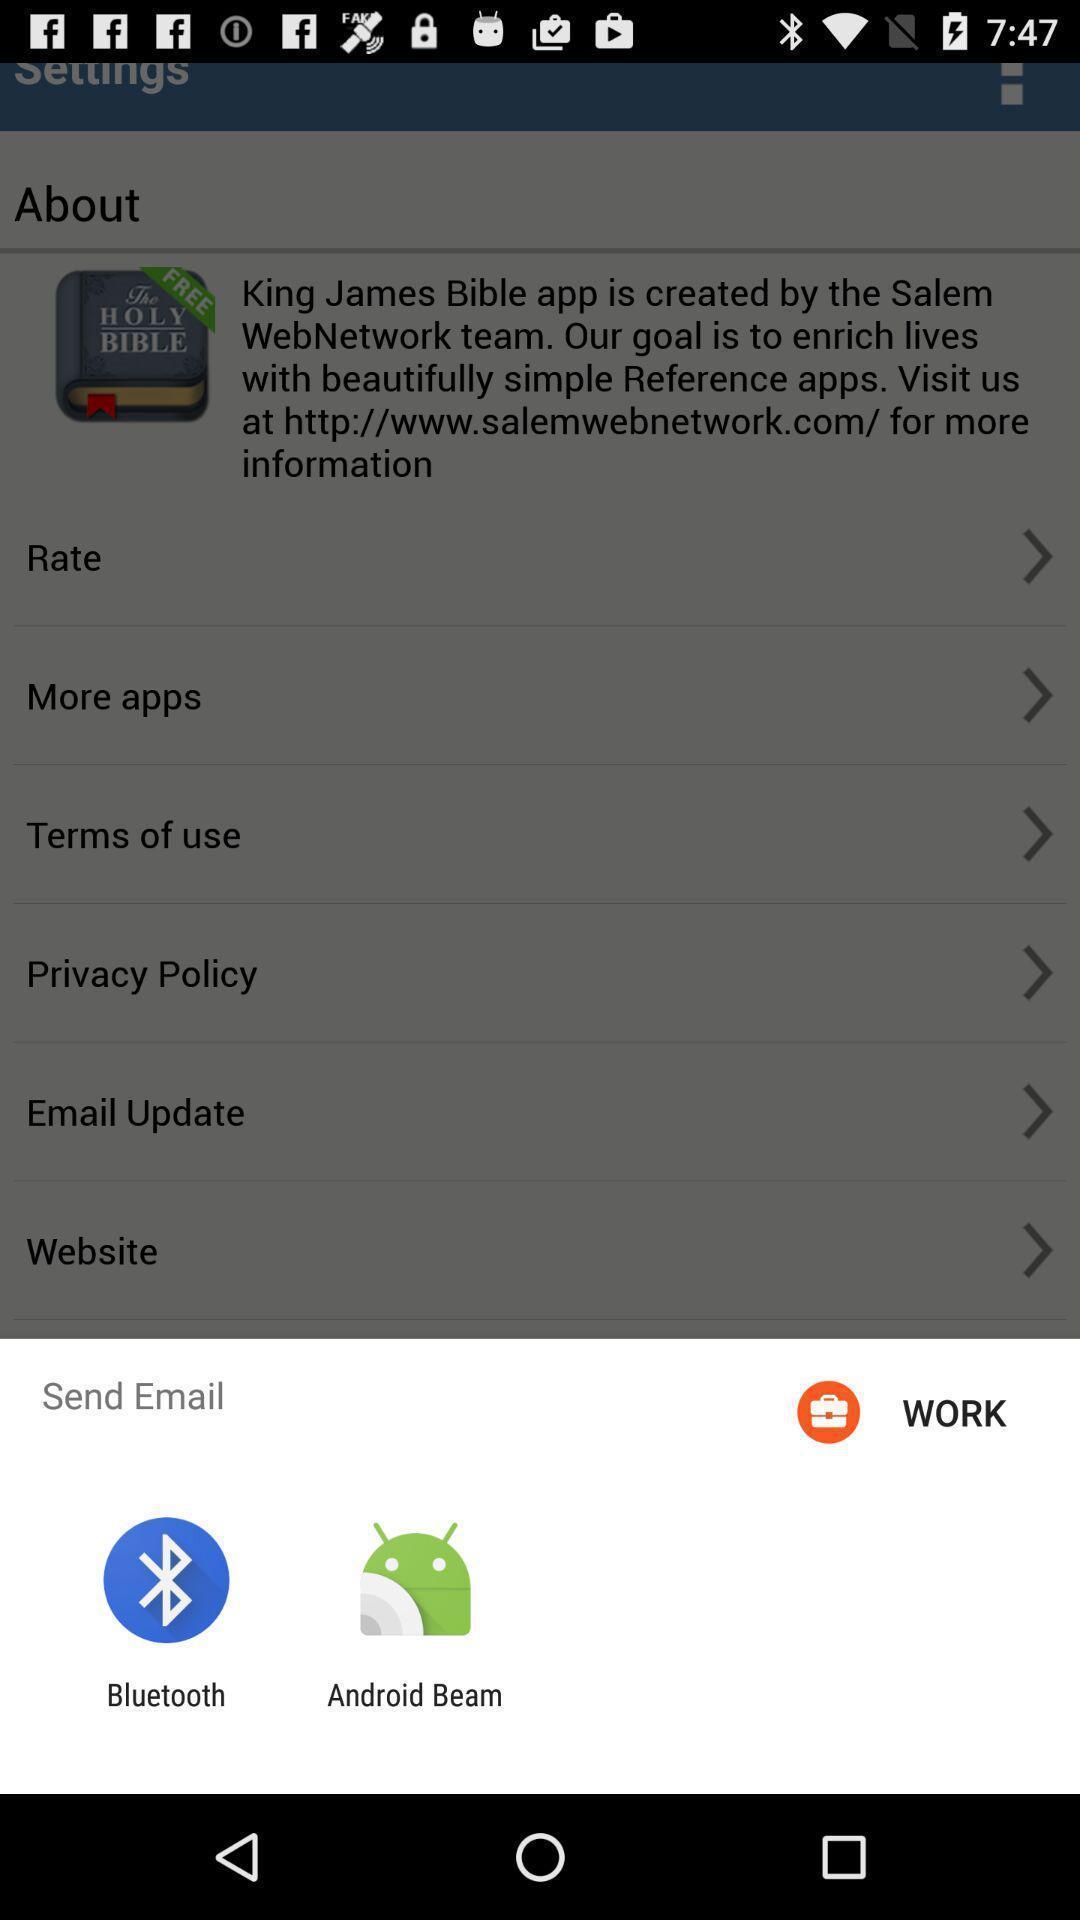Give me a narrative description of this picture. Screen shows sens email through an application. 